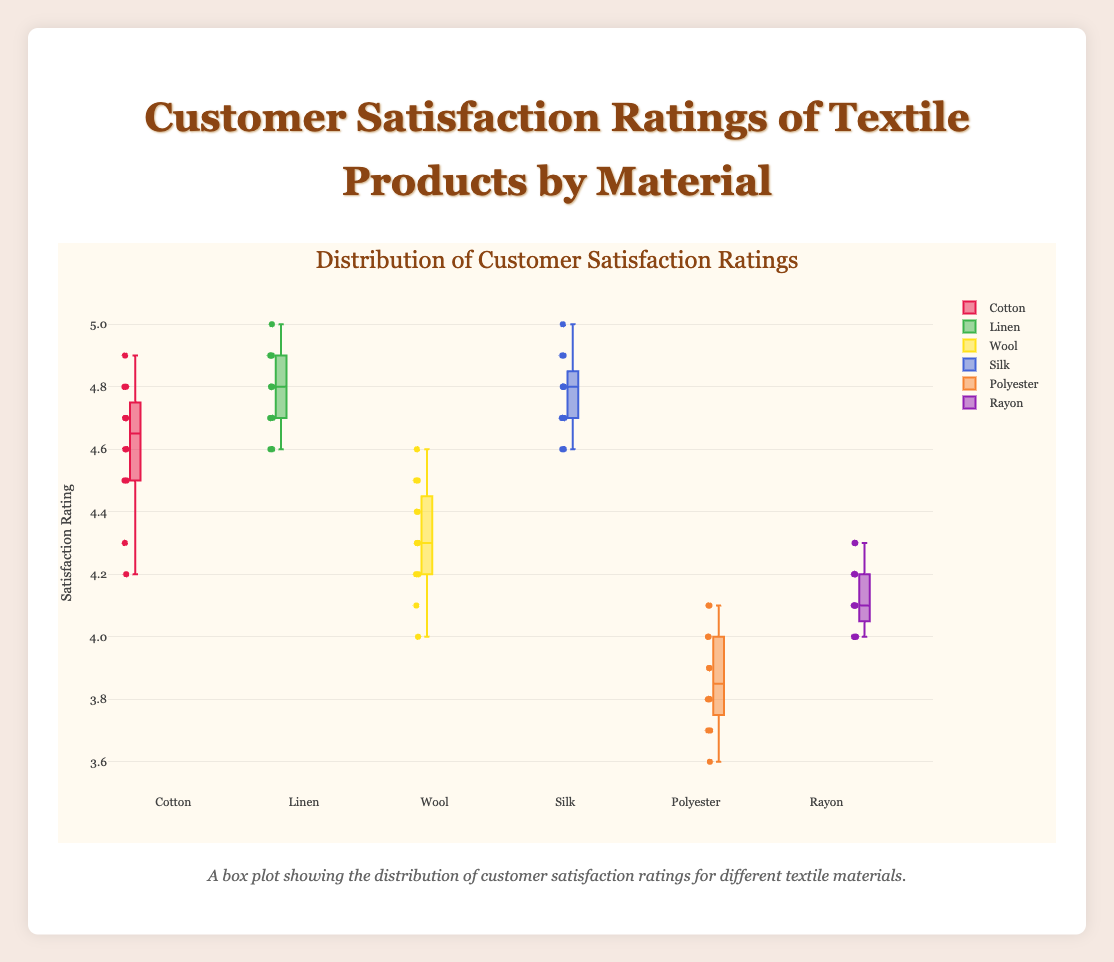What is the title of the box plot? Look at the top of the figure, the title is prominently displayed in a larger font above the plot area.
Answer: Customer Satisfaction Ratings of Textile Products by Material What is the range of satisfaction ratings shown on the y-axis? On the y-axis, the lowest value starts at 3.5 and the highest value reaches 5.1. This can be confirmed by reading the labels on the y-axis.
Answer: 3.5 to 5.1 Which textile material has the highest median customer satisfaction rating? The median is indicated by the line within the box. By comparing the medians of all the boxes, Linen and Silk have the highest medians.
Answer: Linen and Silk How many types of textile materials are compared in this box plot? Count the number of different box charts (each representing a different material) shown in the plot.
Answer: Six Which textile material has the widest range of customer satisfaction ratings? The range in a box plot can be identified by the distance between the minimum and maximum whiskers. Comparing all materials, Cotton has the widest range.
Answer: Cotton Among the materials, which one has the lowest maximum satisfaction rating? The maximum rating is indicated by the top whisker of each box plot. Polyester has the lowest maximum rating.
Answer: Polyester What is the interquartile range (IQR) for Wool? The IQR is the range within the box, representing the middle 50% of the data. For Wool, the lower quartile (Q1) is about 4.2 and the upper quartile (Q3) is about 4.4, so the IQR is 4.4 - 4.2.
Answer: 0.2 Which materials have ratings that include an outlier below 4? Outliers are individual points plotted beyond the whiskers of the box. Wool and Polyester have ratings with outliers below 4.
Answer: Wool and Polyester What's the general trend observed in customer satisfaction between natural (Cotton, Linen, Wool, Silk) and synthetic materials (Polyester, Rayon)? By visually comparing the medians and ranges of the natural and synthetic materials, it's observed that natural materials generally have higher medians and smaller ranges, while synthetic materials show lower medians and wider ranges.
Answer: Natural materials generally higher satisfaction How do the customer satisfaction ratings of Rayon compare to those of Polyester? By comparing both median lines and the overall spread of ratings (box and whiskers), Rayon has higher medians and narrower IQRs/whiskers compared to Polyester.
Answer: Rayon generally higher 